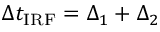<formula> <loc_0><loc_0><loc_500><loc_500>\Delta t _ { I R F } = \Delta _ { 1 } + \Delta _ { 2 }</formula> 